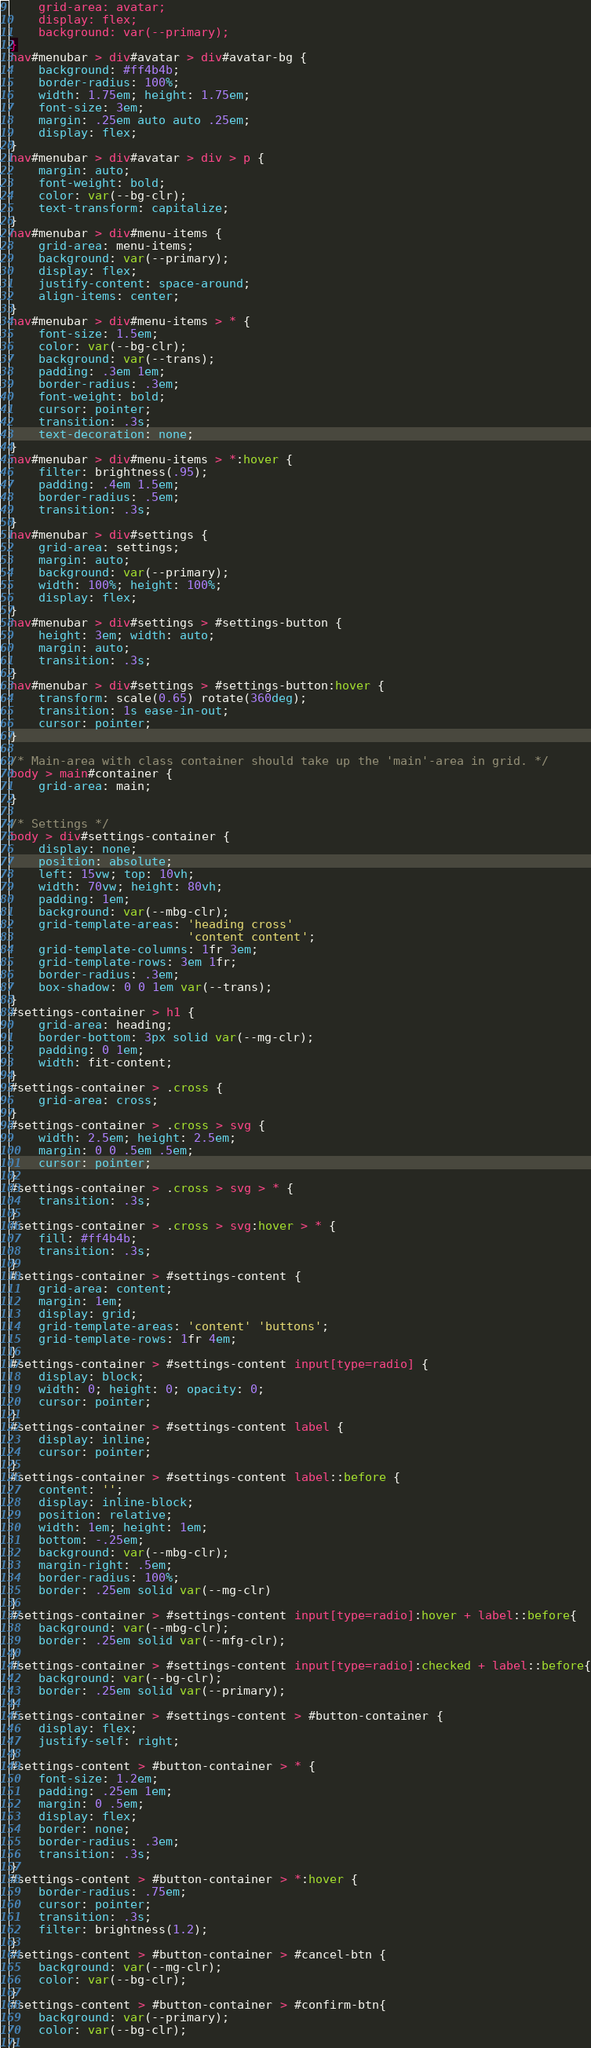Convert code to text. <code><loc_0><loc_0><loc_500><loc_500><_CSS_>    grid-area: avatar;
    display: flex;
    background: var(--primary);
}
nav#menubar > div#avatar > div#avatar-bg {
    background: #ff4b4b;
    border-radius: 100%;
    width: 1.75em; height: 1.75em;
    font-size: 3em;
    margin: .25em auto auto .25em;
    display: flex;
}
nav#menubar > div#avatar > div > p {
    margin: auto;
    font-weight: bold;
    color: var(--bg-clr);
    text-transform: capitalize;
}
nav#menubar > div#menu-items {
    grid-area: menu-items;
    background: var(--primary);
    display: flex;
    justify-content: space-around;
    align-items: center;
}
nav#menubar > div#menu-items > * {
    font-size: 1.5em;
    color: var(--bg-clr);
    background: var(--trans);
    padding: .3em 1em;
    border-radius: .3em;
    font-weight: bold;
    cursor: pointer;
    transition: .3s;
    text-decoration: none;
}
nav#menubar > div#menu-items > *:hover {
    filter: brightness(.95);
    padding: .4em 1.5em;
    border-radius: .5em;
    transition: .3s;
}
nav#menubar > div#settings {
    grid-area: settings;
    margin: auto;
    background: var(--primary);
    width: 100%; height: 100%;
    display: flex;
}
nav#menubar > div#settings > #settings-button {
    height: 3em; width: auto;
    margin: auto;
    transition: .3s;
}
nav#menubar > div#settings > #settings-button:hover {
    transform: scale(0.65) rotate(360deg);
    transition: 1s ease-in-out;
    cursor: pointer;
}

/* Main-area with class container should take up the 'main'-area in grid. */
body > main#container {
    grid-area: main;
}

/* Settings */
body > div#settings-container {
    display: none;
    position: absolute;
    left: 15vw; top: 10vh;
    width: 70vw; height: 80vh;
    padding: 1em;
    background: var(--mbg-clr);
    grid-template-areas: 'heading cross'
                         'content content';
    grid-template-columns: 1fr 3em;
    grid-template-rows: 3em 1fr;
    border-radius: .3em;
    box-shadow: 0 0 1em var(--trans);
}
#settings-container > h1 {
    grid-area: heading;
    border-bottom: 3px solid var(--mg-clr);
    padding: 0 1em;
    width: fit-content;
}
#settings-container > .cross {
    grid-area: cross;
}
#settings-container > .cross > svg {
    width: 2.5em; height: 2.5em;
    margin: 0 0 .5em .5em;
    cursor: pointer;
}
#settings-container > .cross > svg > * {
    transition: .3s;
}
#settings-container > .cross > svg:hover > * {
    fill: #ff4b4b;
    transition: .3s;
}
#settings-container > #settings-content {
    grid-area: content;
    margin: 1em;
    display: grid;
    grid-template-areas: 'content' 'buttons';
    grid-template-rows: 1fr 4em;
}
#settings-container > #settings-content input[type=radio] {
    display: block;
    width: 0; height: 0; opacity: 0;
    cursor: pointer;
}
#settings-container > #settings-content label {
    display: inline;
    cursor: pointer;
}
#settings-container > #settings-content label::before {
    content: '';
    display: inline-block;
    position: relative;
    width: 1em; height: 1em;
    bottom: -.25em;
    background: var(--mbg-clr);
    margin-right: .5em;
    border-radius: 100%;
    border: .25em solid var(--mg-clr)
}
#settings-container > #settings-content input[type=radio]:hover + label::before{
    background: var(--mbg-clr);
    border: .25em solid var(--mfg-clr);
}
#settings-container > #settings-content input[type=radio]:checked + label::before{
    background: var(--bg-clr);
    border: .25em solid var(--primary);
}
#settings-container > #settings-content > #button-container {
    display: flex;
    justify-self: right;
}
#settings-content > #button-container > * {
    font-size: 1.2em;
    padding: .25em 1em;
    margin: 0 .5em;
    display: flex;
    border: none;
    border-radius: .3em;
    transition: .3s;
}
#settings-content > #button-container > *:hover {
    border-radius: .75em;
    cursor: pointer;
    transition: .3s;
    filter: brightness(1.2);
}
#settings-content > #button-container > #cancel-btn {
    background: var(--mg-clr);
    color: var(--bg-clr);
}
#settings-content > #button-container > #confirm-btn{
    background: var(--primary);
    color: var(--bg-clr);
}</code> 